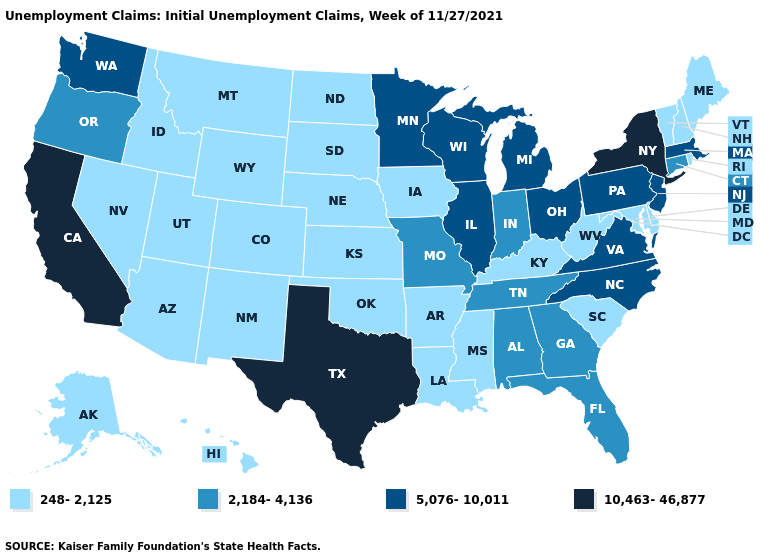What is the value of Idaho?
Concise answer only. 248-2,125. What is the value of Indiana?
Concise answer only. 2,184-4,136. Which states hav the highest value in the South?
Be succinct. Texas. Does Texas have the highest value in the USA?
Write a very short answer. Yes. Is the legend a continuous bar?
Keep it brief. No. What is the value of Massachusetts?
Give a very brief answer. 5,076-10,011. What is the highest value in the USA?
Keep it brief. 10,463-46,877. Name the states that have a value in the range 2,184-4,136?
Keep it brief. Alabama, Connecticut, Florida, Georgia, Indiana, Missouri, Oregon, Tennessee. What is the value of North Carolina?
Quick response, please. 5,076-10,011. Is the legend a continuous bar?
Concise answer only. No. What is the value of Virginia?
Short answer required. 5,076-10,011. What is the value of New York?
Short answer required. 10,463-46,877. Name the states that have a value in the range 5,076-10,011?
Answer briefly. Illinois, Massachusetts, Michigan, Minnesota, New Jersey, North Carolina, Ohio, Pennsylvania, Virginia, Washington, Wisconsin. Does Tennessee have a higher value than Pennsylvania?
Concise answer only. No. What is the value of Florida?
Short answer required. 2,184-4,136. 